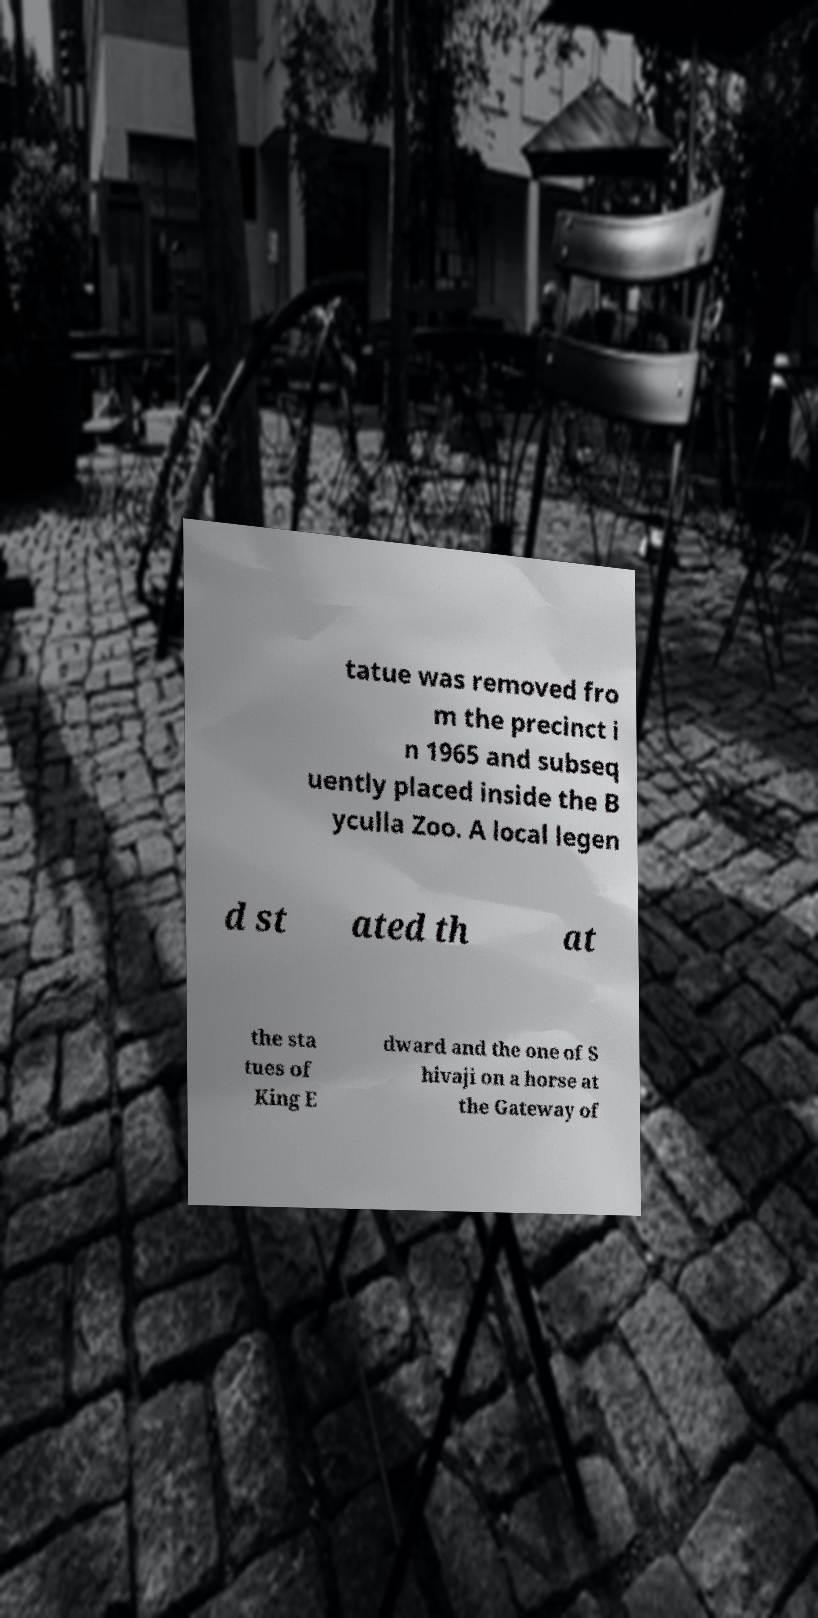Please read and relay the text visible in this image. What does it say? tatue was removed fro m the precinct i n 1965 and subseq uently placed inside the B yculla Zoo. A local legen d st ated th at the sta tues of King E dward and the one of S hivaji on a horse at the Gateway of 